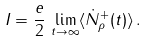Convert formula to latex. <formula><loc_0><loc_0><loc_500><loc_500>I = \frac { e } { 2 } \, \lim _ { t \to \infty } \langle \dot { N } _ { \rho } ^ { + } ( t ) \rangle \, .</formula> 